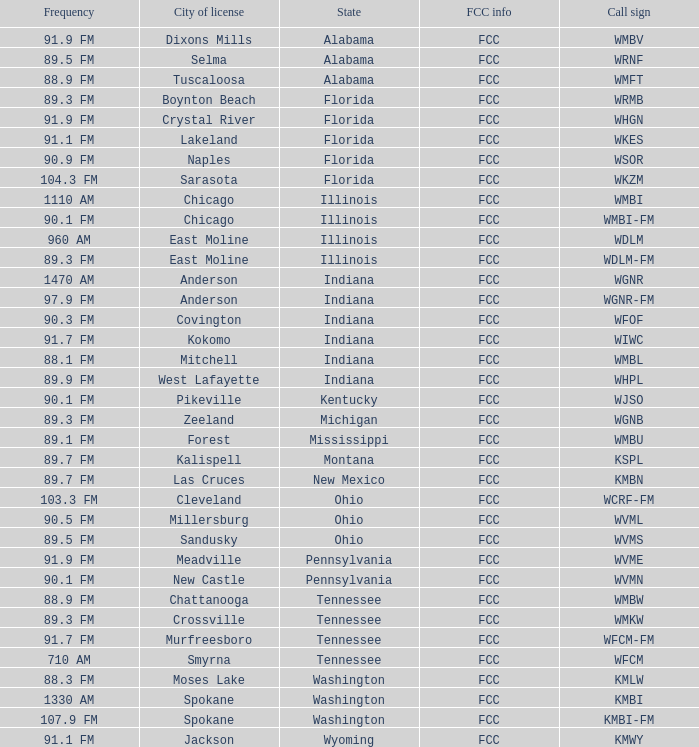What is the FCC info for the radio station in West Lafayette, Indiana? FCC. 